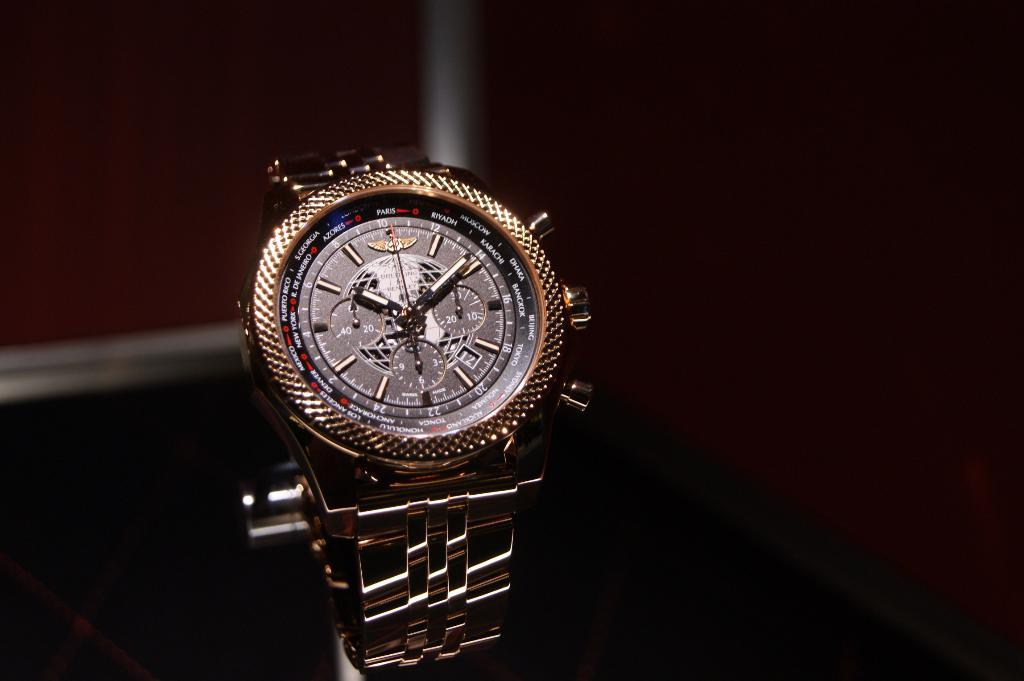<image>
Offer a succinct explanation of the picture presented. A watch showing the time in Paris, New York, and other cities. 